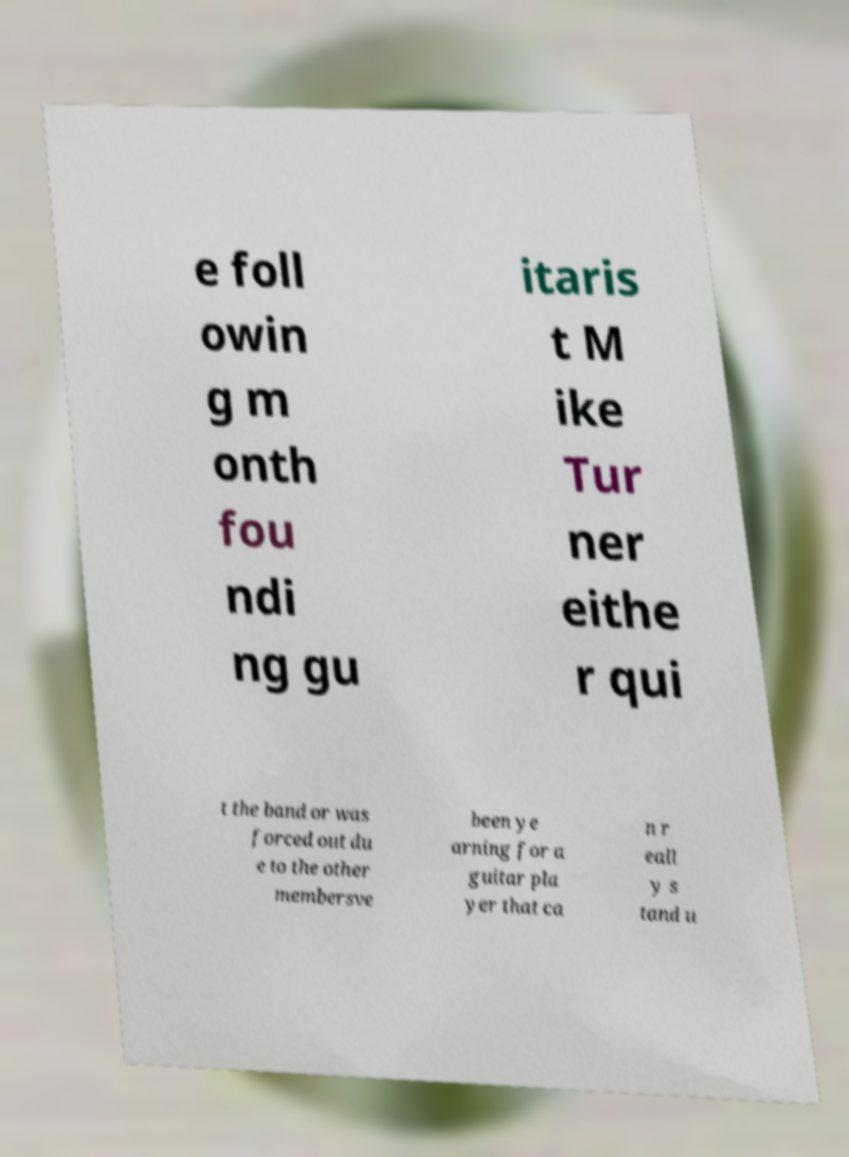What messages or text are displayed in this image? I need them in a readable, typed format. e foll owin g m onth fou ndi ng gu itaris t M ike Tur ner eithe r qui t the band or was forced out du e to the other membersve been ye arning for a guitar pla yer that ca n r eall y s tand u 